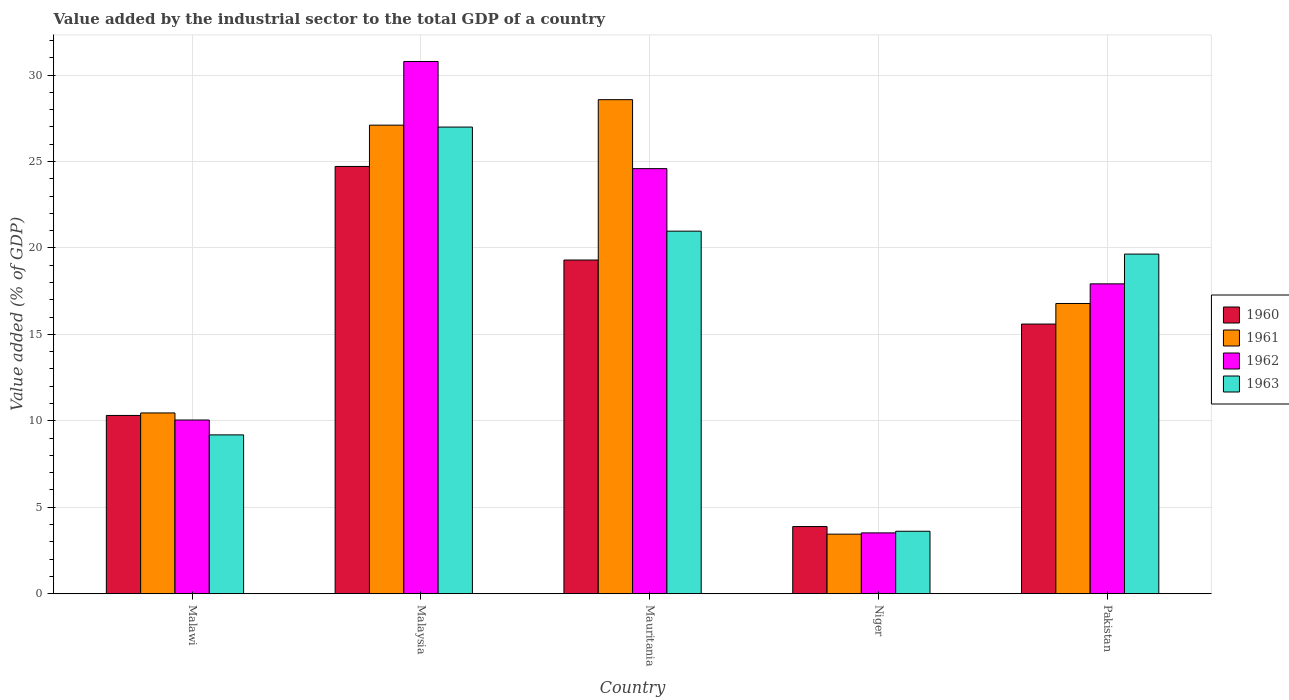Are the number of bars per tick equal to the number of legend labels?
Your answer should be very brief. Yes. How many bars are there on the 3rd tick from the right?
Give a very brief answer. 4. What is the label of the 5th group of bars from the left?
Your answer should be very brief. Pakistan. What is the value added by the industrial sector to the total GDP in 1960 in Mauritania?
Your response must be concise. 19.3. Across all countries, what is the maximum value added by the industrial sector to the total GDP in 1961?
Your answer should be compact. 28.57. Across all countries, what is the minimum value added by the industrial sector to the total GDP in 1961?
Give a very brief answer. 3.45. In which country was the value added by the industrial sector to the total GDP in 1962 maximum?
Your answer should be very brief. Malaysia. In which country was the value added by the industrial sector to the total GDP in 1962 minimum?
Keep it short and to the point. Niger. What is the total value added by the industrial sector to the total GDP in 1961 in the graph?
Provide a short and direct response. 86.36. What is the difference between the value added by the industrial sector to the total GDP in 1963 in Malaysia and that in Pakistan?
Provide a short and direct response. 7.35. What is the difference between the value added by the industrial sector to the total GDP in 1961 in Niger and the value added by the industrial sector to the total GDP in 1963 in Malawi?
Your answer should be very brief. -5.74. What is the average value added by the industrial sector to the total GDP in 1962 per country?
Provide a succinct answer. 17.37. What is the difference between the value added by the industrial sector to the total GDP of/in 1962 and value added by the industrial sector to the total GDP of/in 1961 in Pakistan?
Make the answer very short. 1.14. In how many countries, is the value added by the industrial sector to the total GDP in 1963 greater than 5 %?
Your answer should be compact. 4. What is the ratio of the value added by the industrial sector to the total GDP in 1963 in Malawi to that in Pakistan?
Provide a succinct answer. 0.47. Is the difference between the value added by the industrial sector to the total GDP in 1962 in Malaysia and Niger greater than the difference between the value added by the industrial sector to the total GDP in 1961 in Malaysia and Niger?
Provide a short and direct response. Yes. What is the difference between the highest and the second highest value added by the industrial sector to the total GDP in 1960?
Your answer should be compact. 5.41. What is the difference between the highest and the lowest value added by the industrial sector to the total GDP in 1963?
Offer a very short reply. 23.38. In how many countries, is the value added by the industrial sector to the total GDP in 1962 greater than the average value added by the industrial sector to the total GDP in 1962 taken over all countries?
Your response must be concise. 3. Is the sum of the value added by the industrial sector to the total GDP in 1962 in Malawi and Niger greater than the maximum value added by the industrial sector to the total GDP in 1960 across all countries?
Ensure brevity in your answer.  No. What does the 1st bar from the left in Malawi represents?
Offer a terse response. 1960. Is it the case that in every country, the sum of the value added by the industrial sector to the total GDP in 1963 and value added by the industrial sector to the total GDP in 1960 is greater than the value added by the industrial sector to the total GDP in 1961?
Your answer should be compact. Yes. How many countries are there in the graph?
Provide a short and direct response. 5. What is the difference between two consecutive major ticks on the Y-axis?
Give a very brief answer. 5. Are the values on the major ticks of Y-axis written in scientific E-notation?
Offer a very short reply. No. Does the graph contain grids?
Make the answer very short. Yes. Where does the legend appear in the graph?
Make the answer very short. Center right. How are the legend labels stacked?
Make the answer very short. Vertical. What is the title of the graph?
Ensure brevity in your answer.  Value added by the industrial sector to the total GDP of a country. Does "1979" appear as one of the legend labels in the graph?
Give a very brief answer. No. What is the label or title of the Y-axis?
Make the answer very short. Value added (% of GDP). What is the Value added (% of GDP) in 1960 in Malawi?
Ensure brevity in your answer.  10.31. What is the Value added (% of GDP) in 1961 in Malawi?
Ensure brevity in your answer.  10.46. What is the Value added (% of GDP) in 1962 in Malawi?
Ensure brevity in your answer.  10.05. What is the Value added (% of GDP) of 1963 in Malawi?
Your answer should be compact. 9.19. What is the Value added (% of GDP) of 1960 in Malaysia?
Keep it short and to the point. 24.71. What is the Value added (% of GDP) in 1961 in Malaysia?
Give a very brief answer. 27.1. What is the Value added (% of GDP) in 1962 in Malaysia?
Keep it short and to the point. 30.78. What is the Value added (% of GDP) in 1963 in Malaysia?
Provide a short and direct response. 26.99. What is the Value added (% of GDP) in 1960 in Mauritania?
Keep it short and to the point. 19.3. What is the Value added (% of GDP) of 1961 in Mauritania?
Your answer should be very brief. 28.57. What is the Value added (% of GDP) in 1962 in Mauritania?
Provide a short and direct response. 24.59. What is the Value added (% of GDP) of 1963 in Mauritania?
Your answer should be compact. 20.97. What is the Value added (% of GDP) of 1960 in Niger?
Your answer should be very brief. 3.89. What is the Value added (% of GDP) in 1961 in Niger?
Your answer should be very brief. 3.45. What is the Value added (% of GDP) in 1962 in Niger?
Provide a short and direct response. 3.52. What is the Value added (% of GDP) in 1963 in Niger?
Keep it short and to the point. 3.61. What is the Value added (% of GDP) of 1960 in Pakistan?
Your answer should be compact. 15.6. What is the Value added (% of GDP) in 1961 in Pakistan?
Make the answer very short. 16.79. What is the Value added (% of GDP) in 1962 in Pakistan?
Give a very brief answer. 17.92. What is the Value added (% of GDP) in 1963 in Pakistan?
Provide a short and direct response. 19.64. Across all countries, what is the maximum Value added (% of GDP) in 1960?
Ensure brevity in your answer.  24.71. Across all countries, what is the maximum Value added (% of GDP) in 1961?
Give a very brief answer. 28.57. Across all countries, what is the maximum Value added (% of GDP) of 1962?
Provide a succinct answer. 30.78. Across all countries, what is the maximum Value added (% of GDP) in 1963?
Keep it short and to the point. 26.99. Across all countries, what is the minimum Value added (% of GDP) in 1960?
Provide a succinct answer. 3.89. Across all countries, what is the minimum Value added (% of GDP) of 1961?
Offer a very short reply. 3.45. Across all countries, what is the minimum Value added (% of GDP) in 1962?
Make the answer very short. 3.52. Across all countries, what is the minimum Value added (% of GDP) of 1963?
Offer a terse response. 3.61. What is the total Value added (% of GDP) of 1960 in the graph?
Keep it short and to the point. 73.81. What is the total Value added (% of GDP) of 1961 in the graph?
Offer a very short reply. 86.36. What is the total Value added (% of GDP) in 1962 in the graph?
Your answer should be compact. 86.86. What is the total Value added (% of GDP) of 1963 in the graph?
Your response must be concise. 80.4. What is the difference between the Value added (% of GDP) of 1960 in Malawi and that in Malaysia?
Provide a short and direct response. -14.4. What is the difference between the Value added (% of GDP) in 1961 in Malawi and that in Malaysia?
Your answer should be very brief. -16.64. What is the difference between the Value added (% of GDP) in 1962 in Malawi and that in Malaysia?
Your response must be concise. -20.73. What is the difference between the Value added (% of GDP) in 1963 in Malawi and that in Malaysia?
Your response must be concise. -17.8. What is the difference between the Value added (% of GDP) of 1960 in Malawi and that in Mauritania?
Provide a short and direct response. -8.99. What is the difference between the Value added (% of GDP) of 1961 in Malawi and that in Mauritania?
Keep it short and to the point. -18.12. What is the difference between the Value added (% of GDP) of 1962 in Malawi and that in Mauritania?
Keep it short and to the point. -14.54. What is the difference between the Value added (% of GDP) in 1963 in Malawi and that in Mauritania?
Your response must be concise. -11.78. What is the difference between the Value added (% of GDP) in 1960 in Malawi and that in Niger?
Make the answer very short. 6.43. What is the difference between the Value added (% of GDP) of 1961 in Malawi and that in Niger?
Offer a terse response. 7.01. What is the difference between the Value added (% of GDP) in 1962 in Malawi and that in Niger?
Your answer should be compact. 6.53. What is the difference between the Value added (% of GDP) in 1963 in Malawi and that in Niger?
Provide a short and direct response. 5.57. What is the difference between the Value added (% of GDP) of 1960 in Malawi and that in Pakistan?
Your answer should be very brief. -5.29. What is the difference between the Value added (% of GDP) of 1961 in Malawi and that in Pakistan?
Ensure brevity in your answer.  -6.33. What is the difference between the Value added (% of GDP) in 1962 in Malawi and that in Pakistan?
Your response must be concise. -7.87. What is the difference between the Value added (% of GDP) in 1963 in Malawi and that in Pakistan?
Your response must be concise. -10.46. What is the difference between the Value added (% of GDP) of 1960 in Malaysia and that in Mauritania?
Give a very brief answer. 5.41. What is the difference between the Value added (% of GDP) in 1961 in Malaysia and that in Mauritania?
Your answer should be very brief. -1.47. What is the difference between the Value added (% of GDP) of 1962 in Malaysia and that in Mauritania?
Your answer should be compact. 6.2. What is the difference between the Value added (% of GDP) in 1963 in Malaysia and that in Mauritania?
Give a very brief answer. 6.02. What is the difference between the Value added (% of GDP) in 1960 in Malaysia and that in Niger?
Your answer should be compact. 20.83. What is the difference between the Value added (% of GDP) in 1961 in Malaysia and that in Niger?
Offer a terse response. 23.65. What is the difference between the Value added (% of GDP) of 1962 in Malaysia and that in Niger?
Ensure brevity in your answer.  27.26. What is the difference between the Value added (% of GDP) in 1963 in Malaysia and that in Niger?
Ensure brevity in your answer.  23.38. What is the difference between the Value added (% of GDP) in 1960 in Malaysia and that in Pakistan?
Keep it short and to the point. 9.11. What is the difference between the Value added (% of GDP) in 1961 in Malaysia and that in Pakistan?
Your answer should be compact. 10.31. What is the difference between the Value added (% of GDP) of 1962 in Malaysia and that in Pakistan?
Give a very brief answer. 12.86. What is the difference between the Value added (% of GDP) of 1963 in Malaysia and that in Pakistan?
Provide a short and direct response. 7.35. What is the difference between the Value added (% of GDP) in 1960 in Mauritania and that in Niger?
Keep it short and to the point. 15.41. What is the difference between the Value added (% of GDP) of 1961 in Mauritania and that in Niger?
Offer a terse response. 25.13. What is the difference between the Value added (% of GDP) of 1962 in Mauritania and that in Niger?
Keep it short and to the point. 21.07. What is the difference between the Value added (% of GDP) in 1963 in Mauritania and that in Niger?
Your response must be concise. 17.36. What is the difference between the Value added (% of GDP) of 1960 in Mauritania and that in Pakistan?
Offer a terse response. 3.7. What is the difference between the Value added (% of GDP) of 1961 in Mauritania and that in Pakistan?
Your answer should be compact. 11.79. What is the difference between the Value added (% of GDP) of 1962 in Mauritania and that in Pakistan?
Your answer should be compact. 6.66. What is the difference between the Value added (% of GDP) of 1963 in Mauritania and that in Pakistan?
Provide a short and direct response. 1.33. What is the difference between the Value added (% of GDP) of 1960 in Niger and that in Pakistan?
Give a very brief answer. -11.71. What is the difference between the Value added (% of GDP) in 1961 in Niger and that in Pakistan?
Offer a terse response. -13.34. What is the difference between the Value added (% of GDP) in 1962 in Niger and that in Pakistan?
Make the answer very short. -14.4. What is the difference between the Value added (% of GDP) of 1963 in Niger and that in Pakistan?
Keep it short and to the point. -16.03. What is the difference between the Value added (% of GDP) in 1960 in Malawi and the Value added (% of GDP) in 1961 in Malaysia?
Make the answer very short. -16.79. What is the difference between the Value added (% of GDP) of 1960 in Malawi and the Value added (% of GDP) of 1962 in Malaysia?
Your answer should be compact. -20.47. What is the difference between the Value added (% of GDP) in 1960 in Malawi and the Value added (% of GDP) in 1963 in Malaysia?
Offer a very short reply. -16.68. What is the difference between the Value added (% of GDP) of 1961 in Malawi and the Value added (% of GDP) of 1962 in Malaysia?
Keep it short and to the point. -20.33. What is the difference between the Value added (% of GDP) in 1961 in Malawi and the Value added (% of GDP) in 1963 in Malaysia?
Offer a terse response. -16.53. What is the difference between the Value added (% of GDP) of 1962 in Malawi and the Value added (% of GDP) of 1963 in Malaysia?
Provide a short and direct response. -16.94. What is the difference between the Value added (% of GDP) of 1960 in Malawi and the Value added (% of GDP) of 1961 in Mauritania?
Ensure brevity in your answer.  -18.26. What is the difference between the Value added (% of GDP) of 1960 in Malawi and the Value added (% of GDP) of 1962 in Mauritania?
Your answer should be very brief. -14.27. What is the difference between the Value added (% of GDP) in 1960 in Malawi and the Value added (% of GDP) in 1963 in Mauritania?
Make the answer very short. -10.66. What is the difference between the Value added (% of GDP) of 1961 in Malawi and the Value added (% of GDP) of 1962 in Mauritania?
Ensure brevity in your answer.  -14.13. What is the difference between the Value added (% of GDP) in 1961 in Malawi and the Value added (% of GDP) in 1963 in Mauritania?
Your answer should be very brief. -10.51. What is the difference between the Value added (% of GDP) in 1962 in Malawi and the Value added (% of GDP) in 1963 in Mauritania?
Give a very brief answer. -10.92. What is the difference between the Value added (% of GDP) in 1960 in Malawi and the Value added (% of GDP) in 1961 in Niger?
Provide a short and direct response. 6.86. What is the difference between the Value added (% of GDP) of 1960 in Malawi and the Value added (% of GDP) of 1962 in Niger?
Your answer should be compact. 6.79. What is the difference between the Value added (% of GDP) in 1960 in Malawi and the Value added (% of GDP) in 1963 in Niger?
Your response must be concise. 6.7. What is the difference between the Value added (% of GDP) of 1961 in Malawi and the Value added (% of GDP) of 1962 in Niger?
Give a very brief answer. 6.94. What is the difference between the Value added (% of GDP) of 1961 in Malawi and the Value added (% of GDP) of 1963 in Niger?
Ensure brevity in your answer.  6.84. What is the difference between the Value added (% of GDP) of 1962 in Malawi and the Value added (% of GDP) of 1963 in Niger?
Your response must be concise. 6.43. What is the difference between the Value added (% of GDP) in 1960 in Malawi and the Value added (% of GDP) in 1961 in Pakistan?
Your response must be concise. -6.48. What is the difference between the Value added (% of GDP) in 1960 in Malawi and the Value added (% of GDP) in 1962 in Pakistan?
Provide a short and direct response. -7.61. What is the difference between the Value added (% of GDP) in 1960 in Malawi and the Value added (% of GDP) in 1963 in Pakistan?
Ensure brevity in your answer.  -9.33. What is the difference between the Value added (% of GDP) of 1961 in Malawi and the Value added (% of GDP) of 1962 in Pakistan?
Make the answer very short. -7.47. What is the difference between the Value added (% of GDP) of 1961 in Malawi and the Value added (% of GDP) of 1963 in Pakistan?
Give a very brief answer. -9.19. What is the difference between the Value added (% of GDP) of 1962 in Malawi and the Value added (% of GDP) of 1963 in Pakistan?
Offer a terse response. -9.6. What is the difference between the Value added (% of GDP) in 1960 in Malaysia and the Value added (% of GDP) in 1961 in Mauritania?
Provide a succinct answer. -3.86. What is the difference between the Value added (% of GDP) of 1960 in Malaysia and the Value added (% of GDP) of 1962 in Mauritania?
Provide a succinct answer. 0.13. What is the difference between the Value added (% of GDP) of 1960 in Malaysia and the Value added (% of GDP) of 1963 in Mauritania?
Your response must be concise. 3.74. What is the difference between the Value added (% of GDP) of 1961 in Malaysia and the Value added (% of GDP) of 1962 in Mauritania?
Your answer should be compact. 2.51. What is the difference between the Value added (% of GDP) of 1961 in Malaysia and the Value added (% of GDP) of 1963 in Mauritania?
Keep it short and to the point. 6.13. What is the difference between the Value added (% of GDP) of 1962 in Malaysia and the Value added (% of GDP) of 1963 in Mauritania?
Your answer should be compact. 9.81. What is the difference between the Value added (% of GDP) of 1960 in Malaysia and the Value added (% of GDP) of 1961 in Niger?
Provide a succinct answer. 21.27. What is the difference between the Value added (% of GDP) in 1960 in Malaysia and the Value added (% of GDP) in 1962 in Niger?
Give a very brief answer. 21.19. What is the difference between the Value added (% of GDP) in 1960 in Malaysia and the Value added (% of GDP) in 1963 in Niger?
Provide a succinct answer. 21.1. What is the difference between the Value added (% of GDP) in 1961 in Malaysia and the Value added (% of GDP) in 1962 in Niger?
Your answer should be very brief. 23.58. What is the difference between the Value added (% of GDP) in 1961 in Malaysia and the Value added (% of GDP) in 1963 in Niger?
Provide a short and direct response. 23.49. What is the difference between the Value added (% of GDP) in 1962 in Malaysia and the Value added (% of GDP) in 1963 in Niger?
Your answer should be very brief. 27.17. What is the difference between the Value added (% of GDP) in 1960 in Malaysia and the Value added (% of GDP) in 1961 in Pakistan?
Provide a short and direct response. 7.92. What is the difference between the Value added (% of GDP) in 1960 in Malaysia and the Value added (% of GDP) in 1962 in Pakistan?
Offer a terse response. 6.79. What is the difference between the Value added (% of GDP) of 1960 in Malaysia and the Value added (% of GDP) of 1963 in Pakistan?
Your answer should be compact. 5.07. What is the difference between the Value added (% of GDP) in 1961 in Malaysia and the Value added (% of GDP) in 1962 in Pakistan?
Your response must be concise. 9.18. What is the difference between the Value added (% of GDP) in 1961 in Malaysia and the Value added (% of GDP) in 1963 in Pakistan?
Make the answer very short. 7.46. What is the difference between the Value added (% of GDP) of 1962 in Malaysia and the Value added (% of GDP) of 1963 in Pakistan?
Your answer should be very brief. 11.14. What is the difference between the Value added (% of GDP) of 1960 in Mauritania and the Value added (% of GDP) of 1961 in Niger?
Offer a terse response. 15.85. What is the difference between the Value added (% of GDP) of 1960 in Mauritania and the Value added (% of GDP) of 1962 in Niger?
Make the answer very short. 15.78. What is the difference between the Value added (% of GDP) of 1960 in Mauritania and the Value added (% of GDP) of 1963 in Niger?
Offer a very short reply. 15.69. What is the difference between the Value added (% of GDP) in 1961 in Mauritania and the Value added (% of GDP) in 1962 in Niger?
Keep it short and to the point. 25.05. What is the difference between the Value added (% of GDP) of 1961 in Mauritania and the Value added (% of GDP) of 1963 in Niger?
Your answer should be very brief. 24.96. What is the difference between the Value added (% of GDP) in 1962 in Mauritania and the Value added (% of GDP) in 1963 in Niger?
Ensure brevity in your answer.  20.97. What is the difference between the Value added (% of GDP) in 1960 in Mauritania and the Value added (% of GDP) in 1961 in Pakistan?
Give a very brief answer. 2.51. What is the difference between the Value added (% of GDP) in 1960 in Mauritania and the Value added (% of GDP) in 1962 in Pakistan?
Your response must be concise. 1.38. What is the difference between the Value added (% of GDP) in 1960 in Mauritania and the Value added (% of GDP) in 1963 in Pakistan?
Your answer should be compact. -0.34. What is the difference between the Value added (% of GDP) in 1961 in Mauritania and the Value added (% of GDP) in 1962 in Pakistan?
Provide a succinct answer. 10.65. What is the difference between the Value added (% of GDP) in 1961 in Mauritania and the Value added (% of GDP) in 1963 in Pakistan?
Your answer should be compact. 8.93. What is the difference between the Value added (% of GDP) of 1962 in Mauritania and the Value added (% of GDP) of 1963 in Pakistan?
Your answer should be compact. 4.94. What is the difference between the Value added (% of GDP) in 1960 in Niger and the Value added (% of GDP) in 1961 in Pakistan?
Give a very brief answer. -12.9. What is the difference between the Value added (% of GDP) in 1960 in Niger and the Value added (% of GDP) in 1962 in Pakistan?
Make the answer very short. -14.04. What is the difference between the Value added (% of GDP) in 1960 in Niger and the Value added (% of GDP) in 1963 in Pakistan?
Provide a short and direct response. -15.76. What is the difference between the Value added (% of GDP) in 1961 in Niger and the Value added (% of GDP) in 1962 in Pakistan?
Keep it short and to the point. -14.48. What is the difference between the Value added (% of GDP) in 1961 in Niger and the Value added (% of GDP) in 1963 in Pakistan?
Your answer should be compact. -16.2. What is the difference between the Value added (% of GDP) in 1962 in Niger and the Value added (% of GDP) in 1963 in Pakistan?
Ensure brevity in your answer.  -16.12. What is the average Value added (% of GDP) in 1960 per country?
Your response must be concise. 14.76. What is the average Value added (% of GDP) of 1961 per country?
Provide a short and direct response. 17.27. What is the average Value added (% of GDP) of 1962 per country?
Offer a terse response. 17.37. What is the average Value added (% of GDP) in 1963 per country?
Ensure brevity in your answer.  16.08. What is the difference between the Value added (% of GDP) in 1960 and Value added (% of GDP) in 1961 in Malawi?
Your answer should be compact. -0.15. What is the difference between the Value added (% of GDP) of 1960 and Value added (% of GDP) of 1962 in Malawi?
Make the answer very short. 0.26. What is the difference between the Value added (% of GDP) of 1960 and Value added (% of GDP) of 1963 in Malawi?
Give a very brief answer. 1.12. What is the difference between the Value added (% of GDP) of 1961 and Value added (% of GDP) of 1962 in Malawi?
Offer a terse response. 0.41. What is the difference between the Value added (% of GDP) of 1961 and Value added (% of GDP) of 1963 in Malawi?
Provide a succinct answer. 1.27. What is the difference between the Value added (% of GDP) in 1962 and Value added (% of GDP) in 1963 in Malawi?
Offer a very short reply. 0.86. What is the difference between the Value added (% of GDP) in 1960 and Value added (% of GDP) in 1961 in Malaysia?
Your answer should be very brief. -2.39. What is the difference between the Value added (% of GDP) of 1960 and Value added (% of GDP) of 1962 in Malaysia?
Make the answer very short. -6.07. What is the difference between the Value added (% of GDP) of 1960 and Value added (% of GDP) of 1963 in Malaysia?
Offer a terse response. -2.28. What is the difference between the Value added (% of GDP) in 1961 and Value added (% of GDP) in 1962 in Malaysia?
Keep it short and to the point. -3.68. What is the difference between the Value added (% of GDP) of 1961 and Value added (% of GDP) of 1963 in Malaysia?
Provide a short and direct response. 0.11. What is the difference between the Value added (% of GDP) of 1962 and Value added (% of GDP) of 1963 in Malaysia?
Your answer should be very brief. 3.79. What is the difference between the Value added (% of GDP) of 1960 and Value added (% of GDP) of 1961 in Mauritania?
Ensure brevity in your answer.  -9.27. What is the difference between the Value added (% of GDP) of 1960 and Value added (% of GDP) of 1962 in Mauritania?
Provide a succinct answer. -5.29. What is the difference between the Value added (% of GDP) in 1960 and Value added (% of GDP) in 1963 in Mauritania?
Offer a very short reply. -1.67. What is the difference between the Value added (% of GDP) in 1961 and Value added (% of GDP) in 1962 in Mauritania?
Provide a succinct answer. 3.99. What is the difference between the Value added (% of GDP) in 1961 and Value added (% of GDP) in 1963 in Mauritania?
Your answer should be very brief. 7.6. What is the difference between the Value added (% of GDP) in 1962 and Value added (% of GDP) in 1963 in Mauritania?
Your response must be concise. 3.62. What is the difference between the Value added (% of GDP) in 1960 and Value added (% of GDP) in 1961 in Niger?
Keep it short and to the point. 0.44. What is the difference between the Value added (% of GDP) of 1960 and Value added (% of GDP) of 1962 in Niger?
Offer a terse response. 0.37. What is the difference between the Value added (% of GDP) of 1960 and Value added (% of GDP) of 1963 in Niger?
Keep it short and to the point. 0.27. What is the difference between the Value added (% of GDP) of 1961 and Value added (% of GDP) of 1962 in Niger?
Make the answer very short. -0.07. What is the difference between the Value added (% of GDP) of 1961 and Value added (% of GDP) of 1963 in Niger?
Offer a terse response. -0.17. What is the difference between the Value added (% of GDP) of 1962 and Value added (% of GDP) of 1963 in Niger?
Provide a succinct answer. -0.09. What is the difference between the Value added (% of GDP) of 1960 and Value added (% of GDP) of 1961 in Pakistan?
Your answer should be very brief. -1.19. What is the difference between the Value added (% of GDP) of 1960 and Value added (% of GDP) of 1962 in Pakistan?
Your answer should be very brief. -2.33. What is the difference between the Value added (% of GDP) in 1960 and Value added (% of GDP) in 1963 in Pakistan?
Offer a very short reply. -4.05. What is the difference between the Value added (% of GDP) of 1961 and Value added (% of GDP) of 1962 in Pakistan?
Your answer should be compact. -1.14. What is the difference between the Value added (% of GDP) of 1961 and Value added (% of GDP) of 1963 in Pakistan?
Your answer should be very brief. -2.86. What is the difference between the Value added (% of GDP) of 1962 and Value added (% of GDP) of 1963 in Pakistan?
Provide a succinct answer. -1.72. What is the ratio of the Value added (% of GDP) of 1960 in Malawi to that in Malaysia?
Offer a very short reply. 0.42. What is the ratio of the Value added (% of GDP) of 1961 in Malawi to that in Malaysia?
Provide a succinct answer. 0.39. What is the ratio of the Value added (% of GDP) of 1962 in Malawi to that in Malaysia?
Your answer should be compact. 0.33. What is the ratio of the Value added (% of GDP) of 1963 in Malawi to that in Malaysia?
Make the answer very short. 0.34. What is the ratio of the Value added (% of GDP) in 1960 in Malawi to that in Mauritania?
Make the answer very short. 0.53. What is the ratio of the Value added (% of GDP) of 1961 in Malawi to that in Mauritania?
Offer a terse response. 0.37. What is the ratio of the Value added (% of GDP) of 1962 in Malawi to that in Mauritania?
Your response must be concise. 0.41. What is the ratio of the Value added (% of GDP) of 1963 in Malawi to that in Mauritania?
Offer a very short reply. 0.44. What is the ratio of the Value added (% of GDP) in 1960 in Malawi to that in Niger?
Give a very brief answer. 2.65. What is the ratio of the Value added (% of GDP) in 1961 in Malawi to that in Niger?
Provide a succinct answer. 3.03. What is the ratio of the Value added (% of GDP) in 1962 in Malawi to that in Niger?
Give a very brief answer. 2.85. What is the ratio of the Value added (% of GDP) of 1963 in Malawi to that in Niger?
Give a very brief answer. 2.54. What is the ratio of the Value added (% of GDP) in 1960 in Malawi to that in Pakistan?
Offer a terse response. 0.66. What is the ratio of the Value added (% of GDP) in 1961 in Malawi to that in Pakistan?
Provide a succinct answer. 0.62. What is the ratio of the Value added (% of GDP) in 1962 in Malawi to that in Pakistan?
Ensure brevity in your answer.  0.56. What is the ratio of the Value added (% of GDP) in 1963 in Malawi to that in Pakistan?
Offer a very short reply. 0.47. What is the ratio of the Value added (% of GDP) in 1960 in Malaysia to that in Mauritania?
Ensure brevity in your answer.  1.28. What is the ratio of the Value added (% of GDP) in 1961 in Malaysia to that in Mauritania?
Offer a terse response. 0.95. What is the ratio of the Value added (% of GDP) in 1962 in Malaysia to that in Mauritania?
Offer a terse response. 1.25. What is the ratio of the Value added (% of GDP) in 1963 in Malaysia to that in Mauritania?
Your answer should be very brief. 1.29. What is the ratio of the Value added (% of GDP) in 1960 in Malaysia to that in Niger?
Make the answer very short. 6.36. What is the ratio of the Value added (% of GDP) of 1961 in Malaysia to that in Niger?
Your answer should be compact. 7.86. What is the ratio of the Value added (% of GDP) in 1962 in Malaysia to that in Niger?
Provide a succinct answer. 8.75. What is the ratio of the Value added (% of GDP) in 1963 in Malaysia to that in Niger?
Your answer should be compact. 7.47. What is the ratio of the Value added (% of GDP) of 1960 in Malaysia to that in Pakistan?
Offer a terse response. 1.58. What is the ratio of the Value added (% of GDP) in 1961 in Malaysia to that in Pakistan?
Keep it short and to the point. 1.61. What is the ratio of the Value added (% of GDP) of 1962 in Malaysia to that in Pakistan?
Keep it short and to the point. 1.72. What is the ratio of the Value added (% of GDP) of 1963 in Malaysia to that in Pakistan?
Your answer should be compact. 1.37. What is the ratio of the Value added (% of GDP) in 1960 in Mauritania to that in Niger?
Provide a short and direct response. 4.97. What is the ratio of the Value added (% of GDP) in 1961 in Mauritania to that in Niger?
Give a very brief answer. 8.29. What is the ratio of the Value added (% of GDP) in 1962 in Mauritania to that in Niger?
Provide a short and direct response. 6.99. What is the ratio of the Value added (% of GDP) in 1963 in Mauritania to that in Niger?
Give a very brief answer. 5.8. What is the ratio of the Value added (% of GDP) of 1960 in Mauritania to that in Pakistan?
Provide a short and direct response. 1.24. What is the ratio of the Value added (% of GDP) of 1961 in Mauritania to that in Pakistan?
Your answer should be very brief. 1.7. What is the ratio of the Value added (% of GDP) in 1962 in Mauritania to that in Pakistan?
Offer a terse response. 1.37. What is the ratio of the Value added (% of GDP) of 1963 in Mauritania to that in Pakistan?
Give a very brief answer. 1.07. What is the ratio of the Value added (% of GDP) in 1960 in Niger to that in Pakistan?
Your answer should be compact. 0.25. What is the ratio of the Value added (% of GDP) of 1961 in Niger to that in Pakistan?
Provide a succinct answer. 0.21. What is the ratio of the Value added (% of GDP) of 1962 in Niger to that in Pakistan?
Keep it short and to the point. 0.2. What is the ratio of the Value added (% of GDP) in 1963 in Niger to that in Pakistan?
Offer a terse response. 0.18. What is the difference between the highest and the second highest Value added (% of GDP) of 1960?
Provide a short and direct response. 5.41. What is the difference between the highest and the second highest Value added (% of GDP) of 1961?
Give a very brief answer. 1.47. What is the difference between the highest and the second highest Value added (% of GDP) of 1962?
Offer a very short reply. 6.2. What is the difference between the highest and the second highest Value added (% of GDP) of 1963?
Offer a very short reply. 6.02. What is the difference between the highest and the lowest Value added (% of GDP) of 1960?
Your response must be concise. 20.83. What is the difference between the highest and the lowest Value added (% of GDP) in 1961?
Give a very brief answer. 25.13. What is the difference between the highest and the lowest Value added (% of GDP) of 1962?
Offer a terse response. 27.26. What is the difference between the highest and the lowest Value added (% of GDP) of 1963?
Offer a terse response. 23.38. 